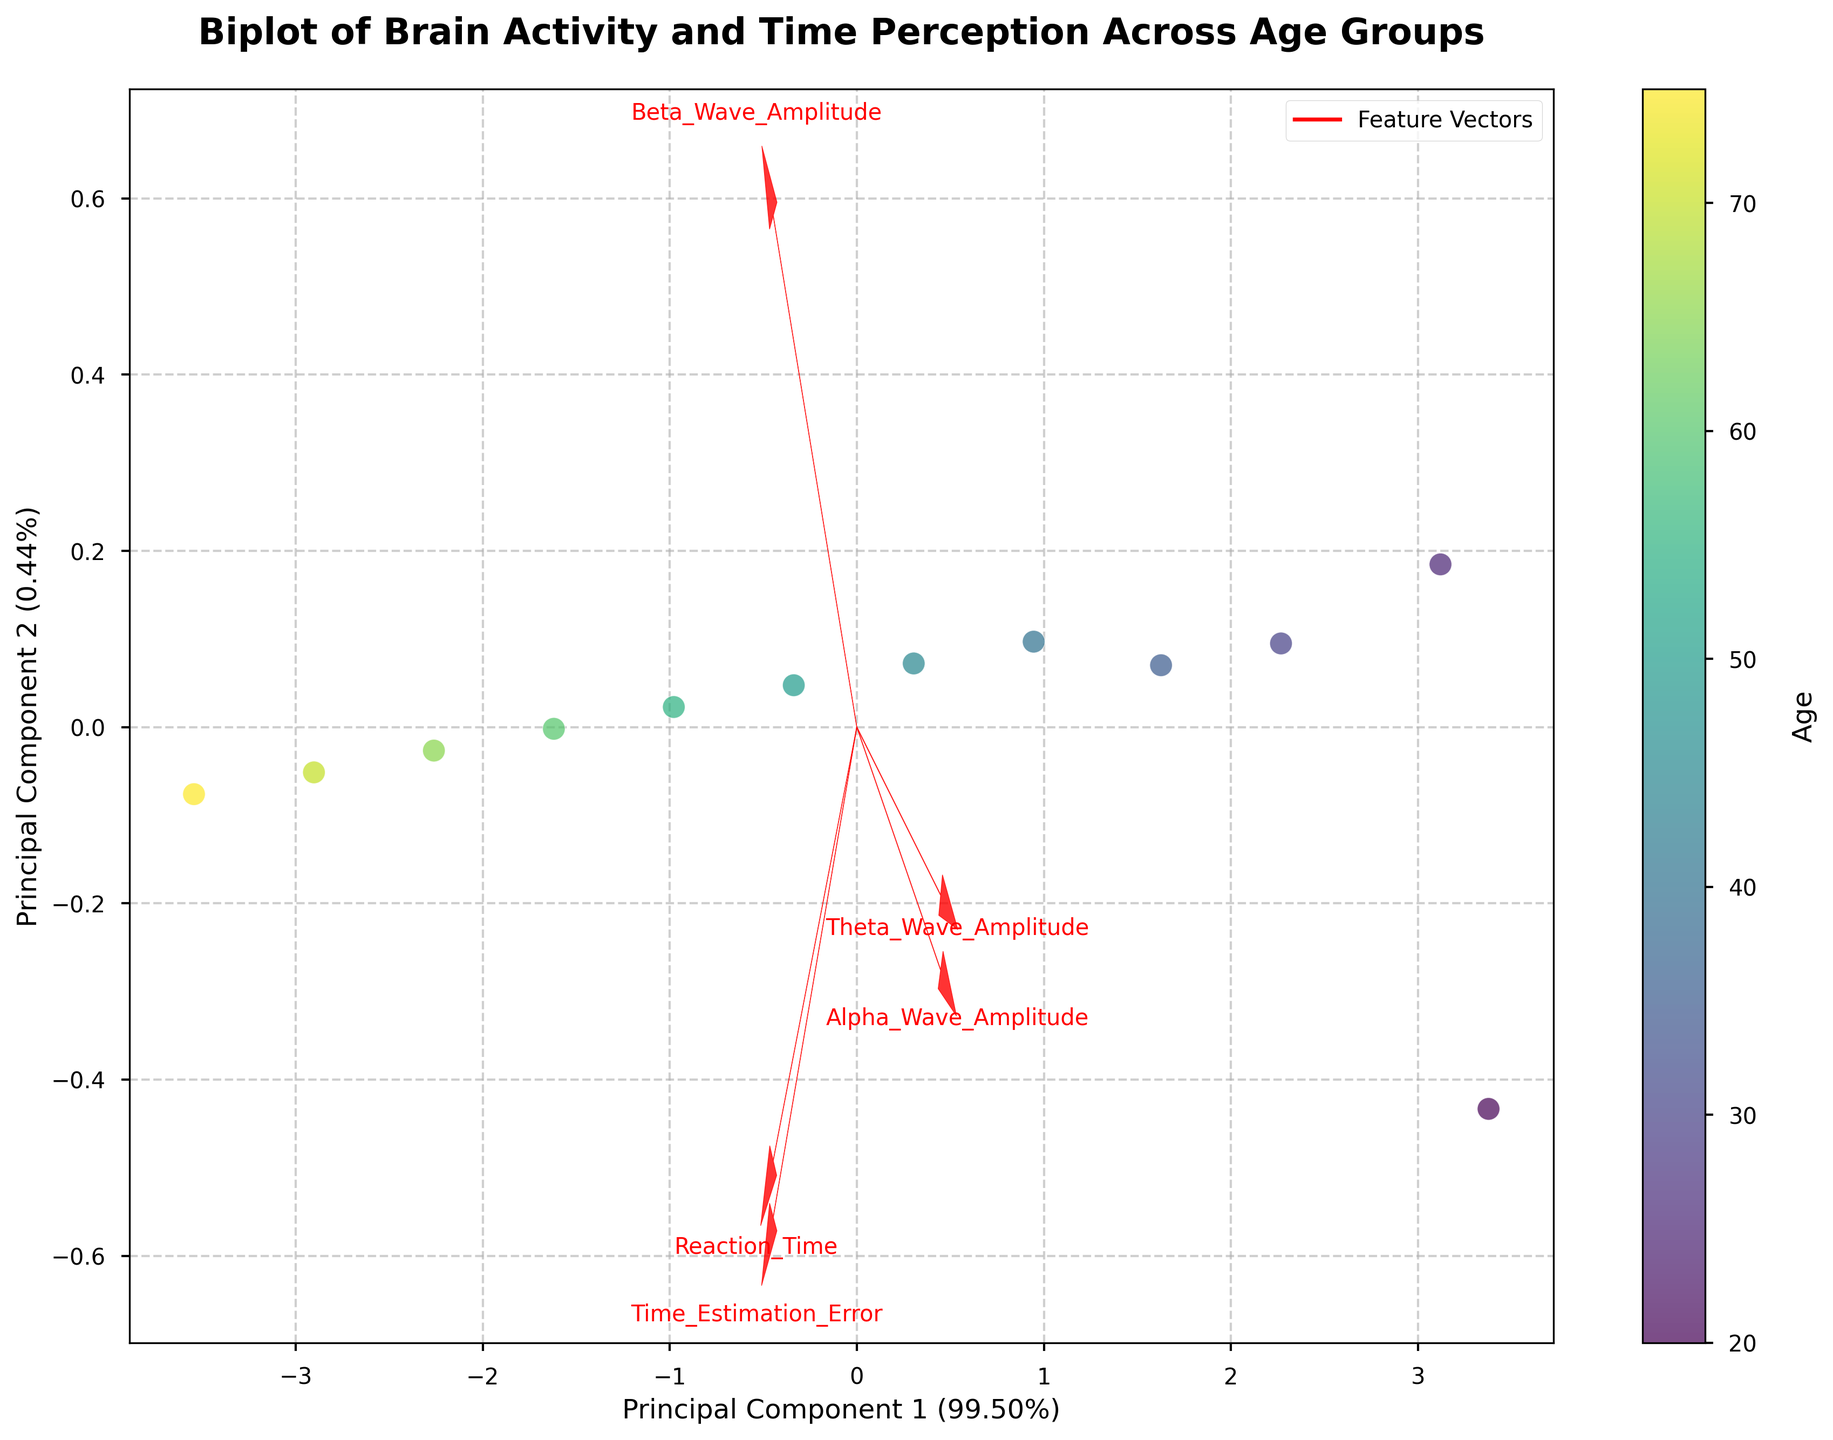What is the title of the biplot? The title of the plot is typically displayed at the top of the figure and is intended to give a brief description of what the figure represents.
Answer: Biplot of Brain Activity and Time Perception Across Age Groups How many features are represented by the vectors in the biplot? The plot includes vectors that originate from the center and extend outward, each representing a feature. The number of vectors corresponds to the number of features.
Answer: 5 What do the color variations in the scatter plot points represent? The color gradient in the scatter plot indicates a variable that changes continuously, often represented by a color bar or legend. In this case, the colorbar showing 'Age' indicates that the colors correspond to different ages.
Answer: Age What is the explained variance ratio for the first principal component? The explained variance ratio is often provided in the labels of the principal components' axes. It indicates how much variance in the data is captured by each principal component.
Answer: Approximately 43% Which feature appears to have the strongest influence on the first principal component? By observing the direction and length of the feature vectors, the one that extends furthest along the x-axis (Principal Component 1) will have the strongest influence.
Answer: Reaction_Time How does the relationship between Reaction Time and Time Estimation Error appear to change with age? By examining the orientation and direction of the vectors relative to the scatter points of different colors, one can infer how these two features change with respect to the color gradient indicating age.
Answer: They both increase with age Compare the positioning of Alpha Wave Amplitude and Beta Wave Amplitude vectors. Which component do they influence more? By examining which axis (Principal Component 1 or Principal Component 2) the vectors are more aligned with, one can determine the component they influence more.
Answer: Beta Wave Amplitude influences Principal Component 1 more; Alpha Wave Amplitude influences Principal Component 2 slightly more Does the Theta Wave Amplitude have a positive or negative correlation with Time Estimation Error? By examining the direction of the vectors, if they point in similar directions, the features they represent are positively correlated; if they point in opposite directions, they are negatively correlated.
Answer: Positive correlation Are younger age groups more towards the left or the right side of the plot? By observing the color gradient and the scatter plot positions, one can determine the location of younger age groups in the plot.
Answer: Left Which feature shows the least variance across the principal components? The feature with the shortest vector length overall contributes the least to both principal components, indicating the least variance.
Answer: Alpha_Wave_Amplitude 